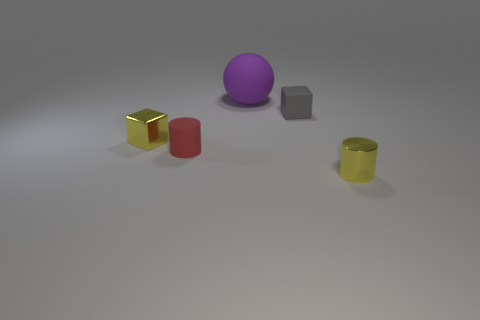Add 1 purple rubber spheres. How many objects exist? 6 Subtract all yellow cubes. How many cubes are left? 1 Subtract all cubes. How many objects are left? 3 Add 5 matte blocks. How many matte blocks are left? 6 Add 5 small blue objects. How many small blue objects exist? 5 Subtract 0 gray spheres. How many objects are left? 5 Subtract all yellow cubes. Subtract all green spheres. How many cubes are left? 1 Subtract all small rubber things. Subtract all cylinders. How many objects are left? 1 